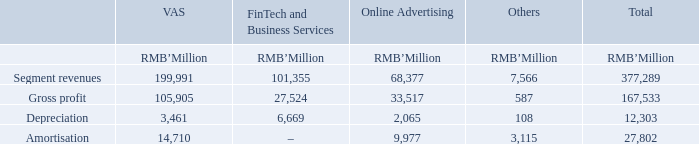(a) Description of segments and principal activities (continued)                                                                                                                   The chief operating decision-makers assess the performance of the operating segments mainly based on segment revenue and gross profit of each operating segment. The selling and marketing expenses and general and administrative expenses are common costs incurred for these operating segments as a whole and therefore, they are not included in the measure of the segments’ performance which is used by the chief operating decisionmakers as a basis for the purpose of resource allocation and assessment of segment performance. Interest income, other gains/(losses), net, finance income/(costs), net, share of profit/(loss) of associates and joint ventures and income tax expense are also not allocated to individual operating segment.
There were no material inter-segment sales during the years ended 31 December 2019 and 2018. The revenues from external customers reported to the chief operating decision-makers are measured in a manner consistent with that applied in the consolidated income statement.
Other information, together with the segment information, provided to the chief operating decision-makers, is measured in a manner consistent with that applied in these consolidated financial statements. There were no segment assets and segment liabilities information provided to the chief operating decision-makers.
The segment information provided to the chief operating decision-makers for the reportable segments for the years ended 31 December 2019 and 2018 is as follows:
How much is the VAS segment revenue?
Answer scale should be: million. 199,991. How much is the VAS gross profit?
Answer scale should be: million. 105,905. How much is the VAS depreciation?
Answer scale should be: million. 3,461. How many percent of total segment revenues is the VAS segment revenue? 
Answer scale should be: percent. 199,991/377,289
Answer: 53.01. How many percent of total depreciation was the VAS depreciation?
Answer scale should be: percent. 3,461/12,303
Answer: 28.13. How many percent of total amortisation was the VAS amortisation?
Answer scale should be: percent. 14,710/27,802
Answer: 52.91. 